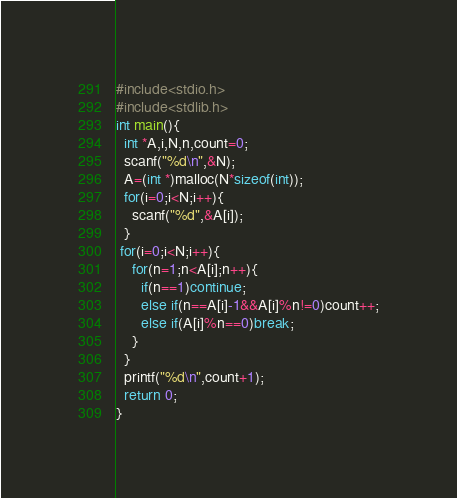Convert code to text. <code><loc_0><loc_0><loc_500><loc_500><_C_>#include<stdio.h>
#include<stdlib.h>
int main(){
  int *A,i,N,n,count=0;
  scanf("%d\n",&N);
  A=(int *)malloc(N*sizeof(int));
  for(i=0;i<N;i++){
    scanf("%d",&A[i]);
  }
 for(i=0;i<N;i++){
    for(n=1;n<A[i];n++){
      if(n==1)continue;
      else if(n==A[i]-1&&A[i]%n!=0)count++;
      else if(A[i]%n==0)break;
    }
  }
  printf("%d\n",count+1);
  return 0;
}

</code> 